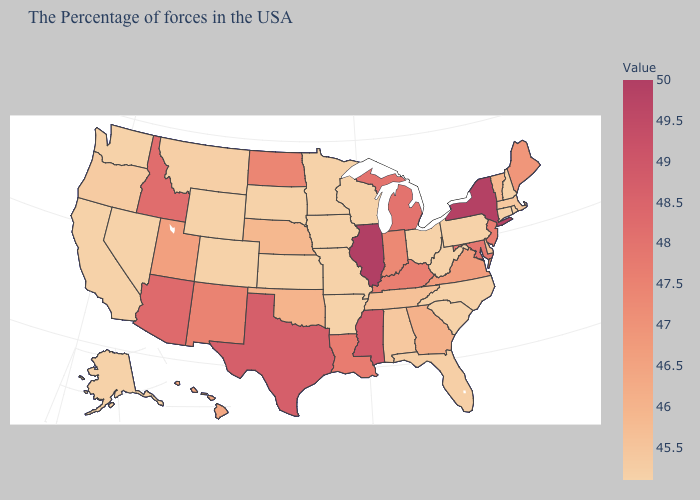Does Hawaii have the lowest value in the West?
Give a very brief answer. No. Among the states that border Vermont , which have the lowest value?
Concise answer only. New Hampshire. Among the states that border North Dakota , which have the lowest value?
Concise answer only. Minnesota, South Dakota. Which states have the lowest value in the USA?
Quick response, please. Rhode Island, New Hampshire, Connecticut, Pennsylvania, North Carolina, South Carolina, West Virginia, Ohio, Wisconsin, Missouri, Arkansas, Minnesota, Iowa, Kansas, South Dakota, Wyoming, Colorado, Nevada, California, Washington, Alaska. Among the states that border Alabama , which have the lowest value?
Short answer required. Florida. 